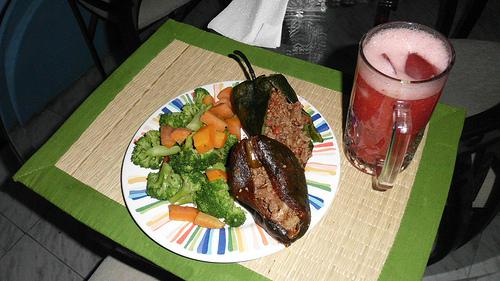Question: what is red?
Choices:
A. The food.
B. Drink.
C. The spoon.
D. The cup.
Answer with the letter. Answer: B Question: what is on the plate?
Choices:
A. Drink.
B. Food.
C. Spoon.
D. Fork.
Answer with the letter. Answer: B Question: what is the plate on?
Choices:
A. The bench.
B. The desk.
C. The table.
D. The bed.
Answer with the letter. Answer: C Question: who will eat?
Choices:
A. Dogs.
B. Cats.
C. Horses.
D. People.
Answer with the letter. Answer: D 